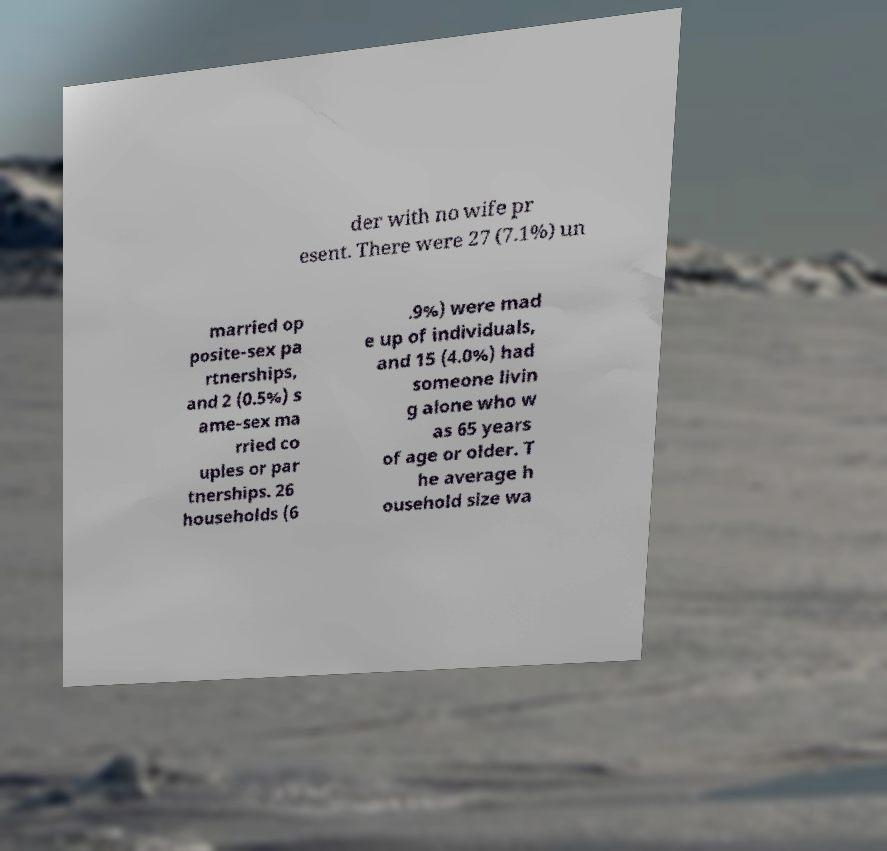Please read and relay the text visible in this image. What does it say? der with no wife pr esent. There were 27 (7.1%) un married op posite-sex pa rtnerships, and 2 (0.5%) s ame-sex ma rried co uples or par tnerships. 26 households (6 .9%) were mad e up of individuals, and 15 (4.0%) had someone livin g alone who w as 65 years of age or older. T he average h ousehold size wa 